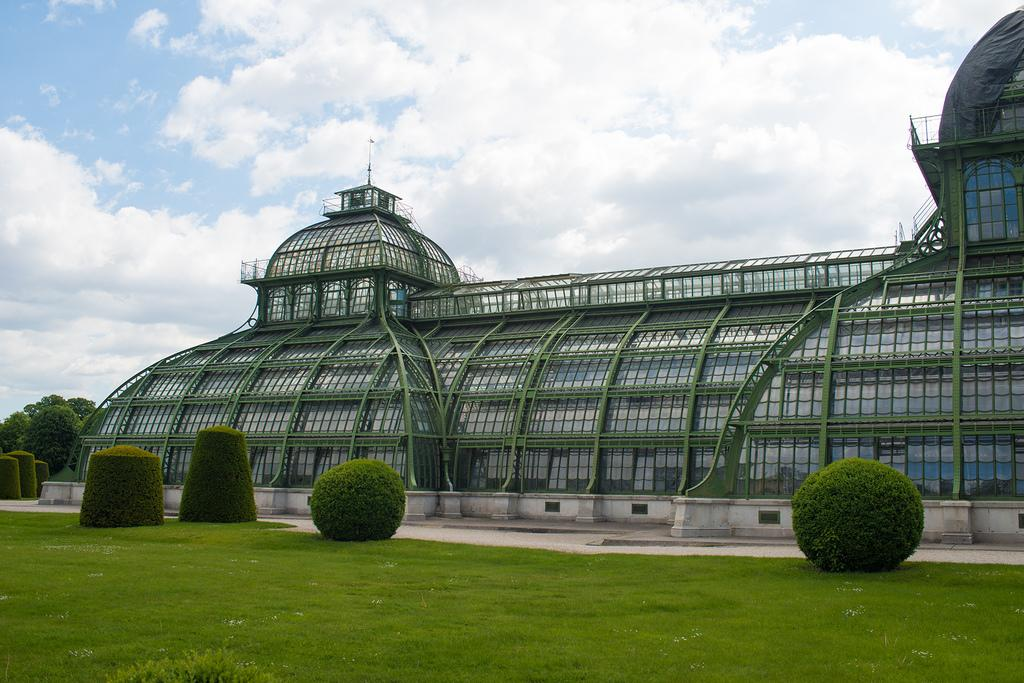What type of structure is present in the picture? There is a building in the picture. What other natural elements can be seen in the picture? There are trees and grass in the picture. What part of the natural environment is visible in the picture? The sky is visible in the background of the picture. What type of fear is depicted in the picture? There is no fear depicted in the picture; it features a building, trees, grass, and the sky. What nation is represented by the structure in the picture? The picture does not depict a specific nation; it only shows a building, trees, grass, and the sky. 